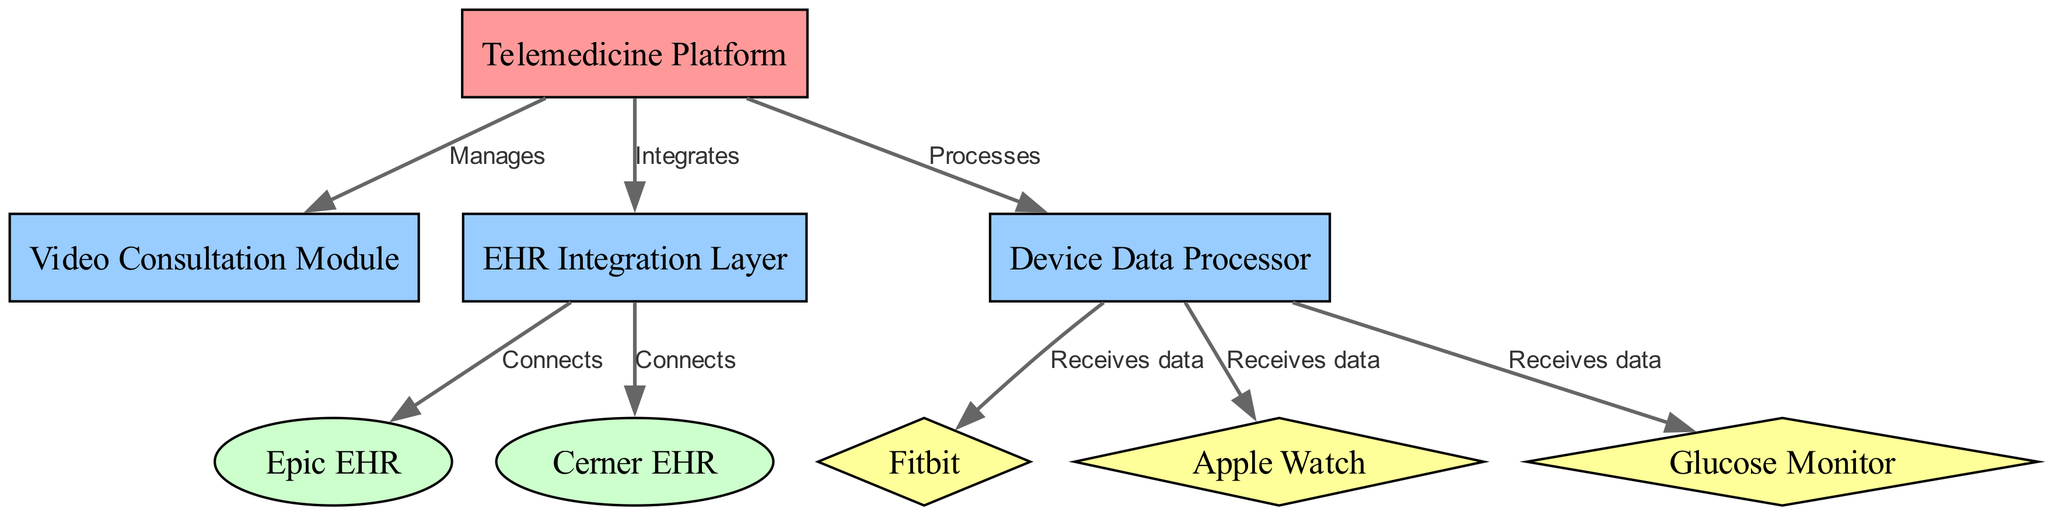What's the central node in the diagram? The central node in the diagram is identified as the "Telemedicine Platform." It serves as the focal point where all other components, external systems, and devices connect.
Answer: Telemedicine Platform How many external EHR systems are represented? The diagram indicates two external EHR systems: "Epic EHR" and "Cerner EHR." These systems are designed to connect with the EHR Integration Layer.
Answer: 2 What type of component manages video consultations? The component designated for managing video consultations is the "Video Consultation Module." It directly relates to the central node, indicating its functional role.
Answer: Video Consultation Module Which devices send data to the Device Data Processor? The devices that send data are "Fitbit," "Apple Watch," and "Glucose Monitor." Each of these devices has a direct connection to the Device Data Processor.
Answer: Fitbit, Apple Watch, Glucose Monitor What type of relationship exists between the Telemedicine Platform and the EHR Integration Layer? The relationship between the Telemedicine Platform and the EHR Integration Layer is described as "Integrates." This indicates that the platform facilitates integration with EHR systems.
Answer: Integrates Which component connects to EHR systems? The component that connects to EHR systems is the "EHR Integration Layer." It serves as the intermediary for linking to external EHRs such as Epic and Cerner.
Answer: EHR Integration Layer How many components are included in the diagram? The diagram includes three components: "Video Consultation Module," "EHR Integration Layer," and "Device Data Processor." These represent the main functionalities of the telemedicine platform.
Answer: 3 What is the flow of data from health devices? Data flows from the "Fitbit," "Apple Watch," and "Glucose Monitor" to the "Device Data Processor," where it is managed and processed for the Telemedicine Platform.
Answer: Device Data Processor What is the label associated with the edge connecting the Telemedicine Platform and the Video Consultation Module? The edge connecting these two nodes is labeled "Manages," indicating the Telemedicine Platform manages the Video Consultation Module's functions.
Answer: Manages 